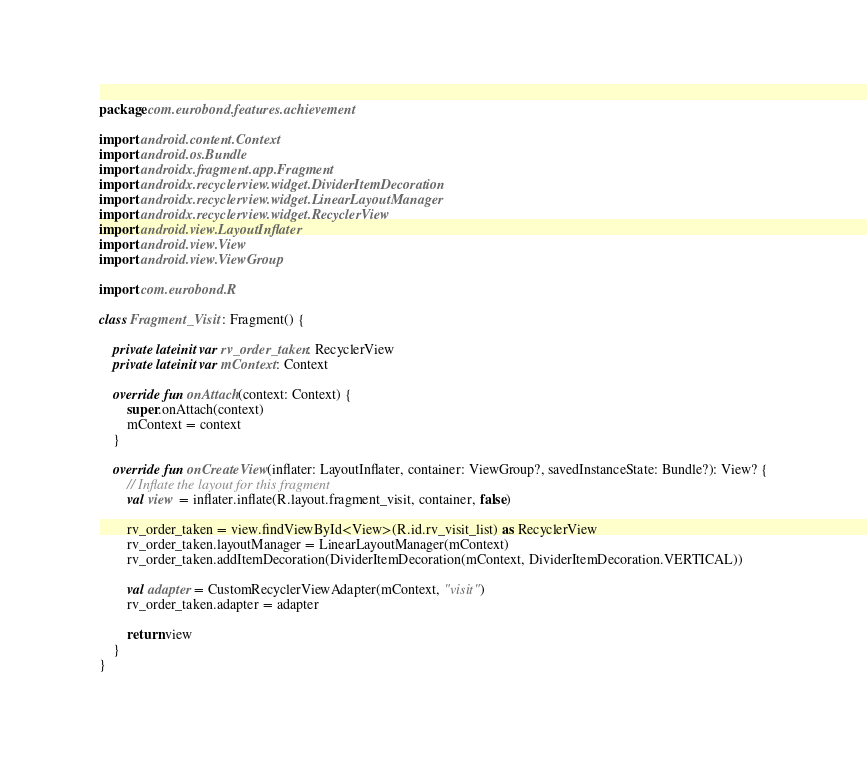<code> <loc_0><loc_0><loc_500><loc_500><_Kotlin_>package com.eurobond.features.achievement

import android.content.Context
import android.os.Bundle
import androidx.fragment.app.Fragment
import androidx.recyclerview.widget.DividerItemDecoration
import androidx.recyclerview.widget.LinearLayoutManager
import androidx.recyclerview.widget.RecyclerView
import android.view.LayoutInflater
import android.view.View
import android.view.ViewGroup

import com.eurobond.R

class Fragment_Visit : Fragment() {

    private lateinit var rv_order_taken: RecyclerView
    private lateinit var mContext: Context

    override fun onAttach(context: Context) {
        super.onAttach(context)
        mContext = context
    }

    override fun onCreateView(inflater: LayoutInflater, container: ViewGroup?, savedInstanceState: Bundle?): View? {
        // Inflate the layout for this fragment
        val view = inflater.inflate(R.layout.fragment_visit, container, false)

        rv_order_taken = view.findViewById<View>(R.id.rv_visit_list) as RecyclerView
        rv_order_taken.layoutManager = LinearLayoutManager(mContext)
        rv_order_taken.addItemDecoration(DividerItemDecoration(mContext, DividerItemDecoration.VERTICAL))

        val adapter = CustomRecyclerViewAdapter(mContext, "visit")
        rv_order_taken.adapter = adapter

        return view
    }
}
</code> 